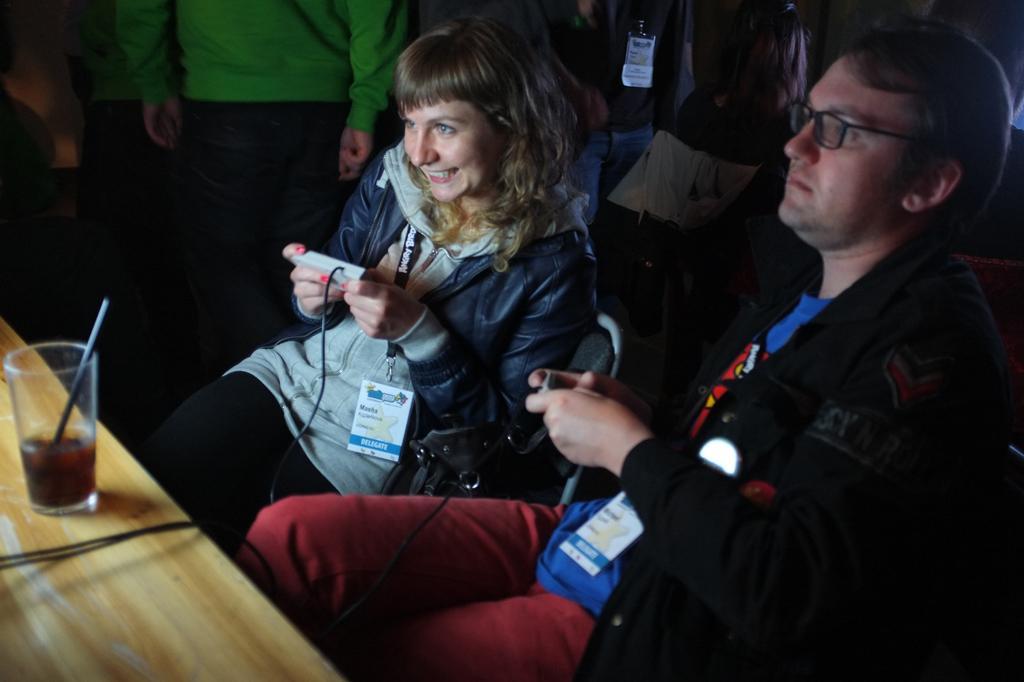Could you give a brief overview of what you see in this image? In this picture we can see people. On a wooden platform we can see drink in the glass with a stirrer. We can see the wires. We can see a woman is holding a device and smiling. We can see a man wearing spectacles and holding a device. 